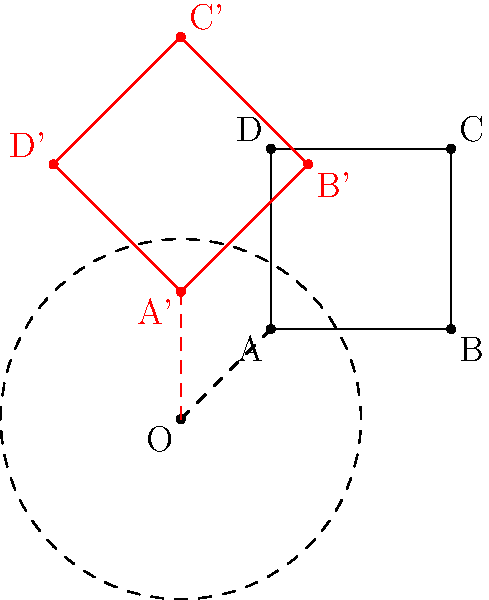A square ABCD with vertices at (1,1), (3,1), (3,3), and (1,3) is rotated 45° counterclockwise around the origin O(0,0). What are the coordinates of vertex A after the rotation? To find the coordinates of vertex A after rotation, we can follow these steps:

1. Identify the initial coordinates of A: (1,1)

2. Use the rotation matrix for a 45° counterclockwise rotation:
   $$R = \begin{bmatrix} \cos 45° & -\sin 45° \\ \sin 45° & \cos 45° \end{bmatrix} = \begin{bmatrix} \frac{\sqrt{2}}{2} & -\frac{\sqrt{2}}{2} \\ \frac{\sqrt{2}}{2} & \frac{\sqrt{2}}{2} \end{bmatrix}$$

3. Apply the rotation matrix to the coordinates of A:
   $$\begin{bmatrix} x' \\ y' \end{bmatrix} = \begin{bmatrix} \frac{\sqrt{2}}{2} & -\frac{\sqrt{2}}{2} \\ \frac{\sqrt{2}}{2} & \frac{\sqrt{2}}{2} \end{bmatrix} \begin{bmatrix} 1 \\ 1 \end{bmatrix}$$

4. Perform the matrix multiplication:
   $$x' = \frac{\sqrt{2}}{2} \cdot 1 - \frac{\sqrt{2}}{2} \cdot 1 = 0$$
   $$y' = \frac{\sqrt{2}}{2} \cdot 1 + \frac{\sqrt{2}}{2} \cdot 1 = \sqrt{2}$$

5. The new coordinates of A after rotation are (0, $\sqrt{2}$)
Answer: (0, $\sqrt{2}$) 